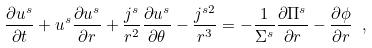<formula> <loc_0><loc_0><loc_500><loc_500>\frac { \partial u ^ { s } } { \partial t } + u ^ { s } \frac { \partial u ^ { s } } { \partial r } + \frac { j ^ { s } } { r ^ { 2 } } \frac { \partial u ^ { s } } { \partial \theta } - \frac { j ^ { s 2 } } { r ^ { 3 } } = - \frac { 1 } { \Sigma ^ { s } } \frac { \partial \Pi ^ { s } } { \partial r } - \frac { \partial \phi } { \partial r } \ ,</formula> 